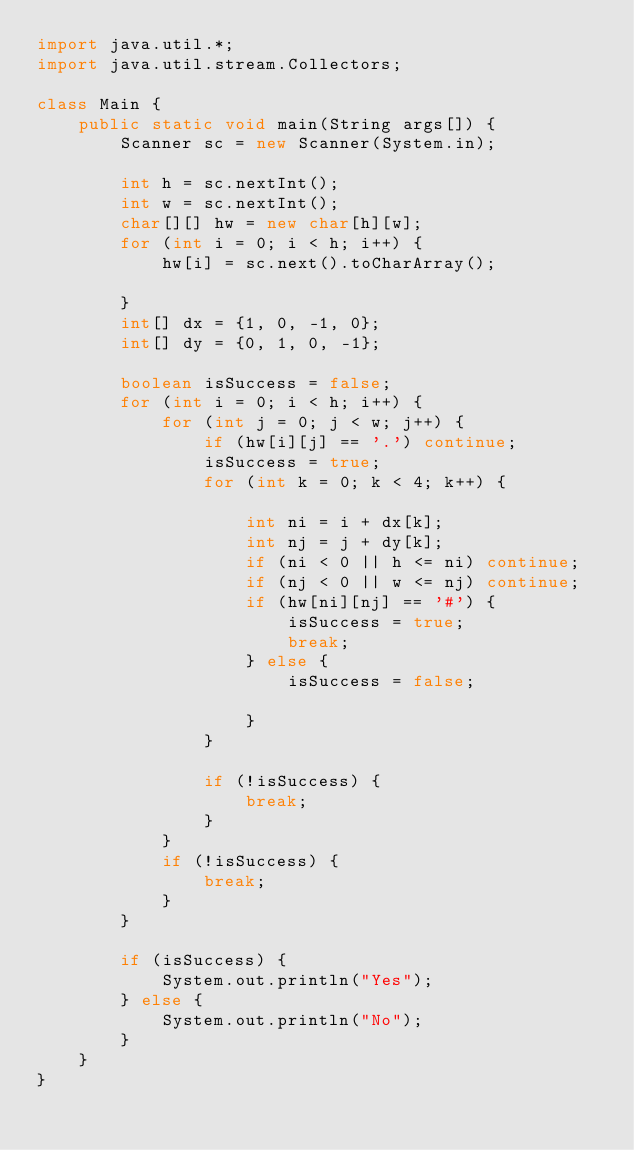Convert code to text. <code><loc_0><loc_0><loc_500><loc_500><_Java_>import java.util.*;
import java.util.stream.Collectors;

class Main {
    public static void main(String args[]) {
        Scanner sc = new Scanner(System.in);
      
        int h = sc.nextInt();
        int w = sc.nextInt();
        char[][] hw = new char[h][w];
        for (int i = 0; i < h; i++) {
            hw[i] = sc.next().toCharArray();

        }
        int[] dx = {1, 0, -1, 0};
        int[] dy = {0, 1, 0, -1};

        boolean isSuccess = false;
        for (int i = 0; i < h; i++) {
            for (int j = 0; j < w; j++) {
                if (hw[i][j] == '.') continue;
                isSuccess = true;
                for (int k = 0; k < 4; k++) {

                    int ni = i + dx[k];
                    int nj = j + dy[k];
                    if (ni < 0 || h <= ni) continue;
                    if (nj < 0 || w <= nj) continue;
                    if (hw[ni][nj] == '#') {
                        isSuccess = true;
                        break;
                    } else {
                        isSuccess = false;

                    }
                }

                if (!isSuccess) {
                    break;
                }
            }
            if (!isSuccess) {
                break;
            }
        }

        if (isSuccess) {
            System.out.println("Yes");
        } else {
            System.out.println("No");
        }
    }
}</code> 